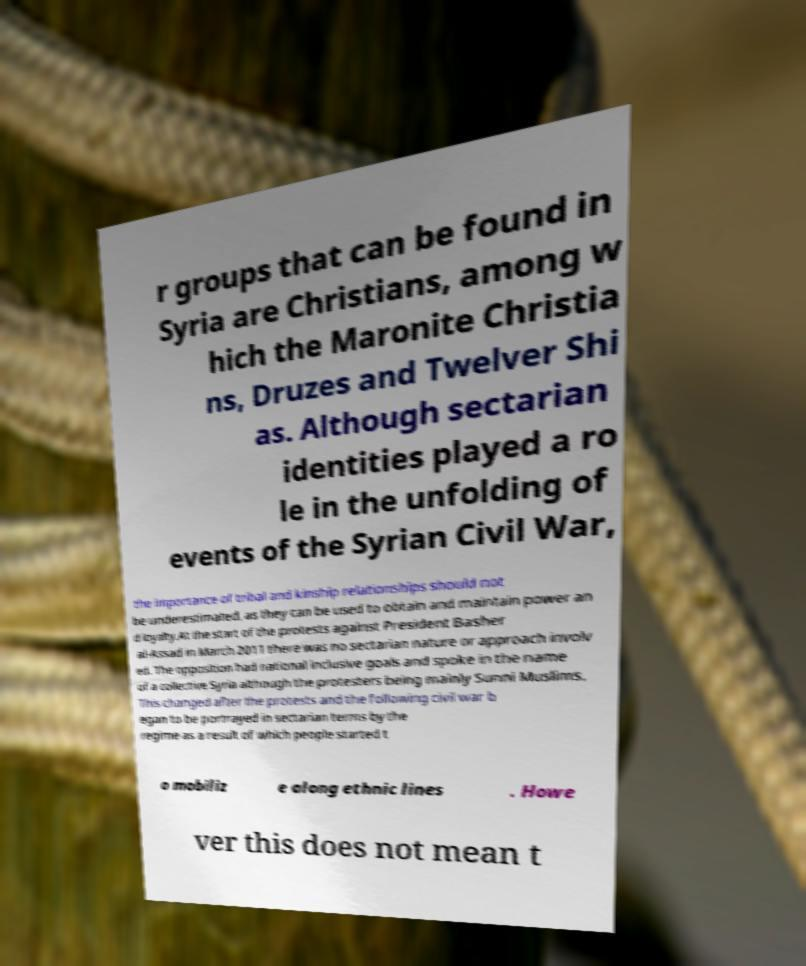Please identify and transcribe the text found in this image. r groups that can be found in Syria are Christians, among w hich the Maronite Christia ns, Druzes and Twelver Shi as. Although sectarian identities played a ro le in the unfolding of events of the Syrian Civil War, the importance of tribal and kinship relationships should not be underestimated, as they can be used to obtain and maintain power an d loyalty.At the start of the protests against President Basher al-Assad in March 2011 there was no sectarian nature or approach involv ed. The opposition had national inclusive goals and spoke in the name of a collective Syria although the protesters being mainly Sunni Muslims. This changed after the protests and the following civil war b egan to be portrayed in sectarian terms by the regime as a result of which people started t o mobiliz e along ethnic lines . Howe ver this does not mean t 